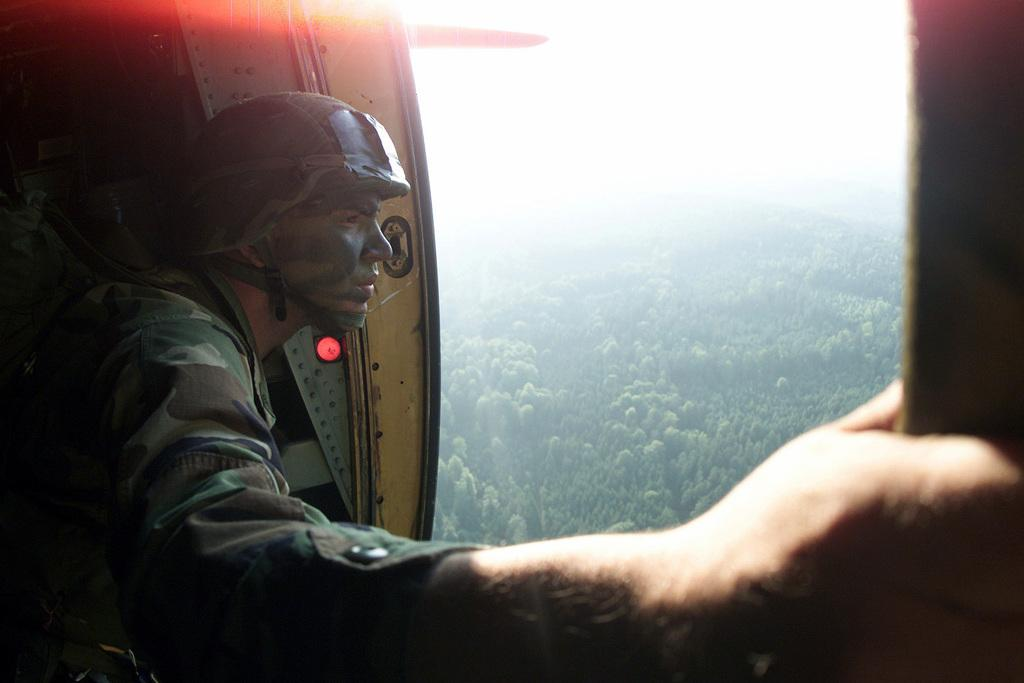What is the person in the image wearing? The person in the image is wearing military dress. What type of headgear is the person wearing? The person is wearing a helmet. What type of natural environment is visible in the image? There are trees visible in the image. What type of key is the person holding in the image? There is no key visible in the image; the person is wearing military dress and a helmet. What type of trains can be seen passing by in the image? There are no trains present in the image; it features a person wearing military dress and a helmet, with trees visible in the background. 